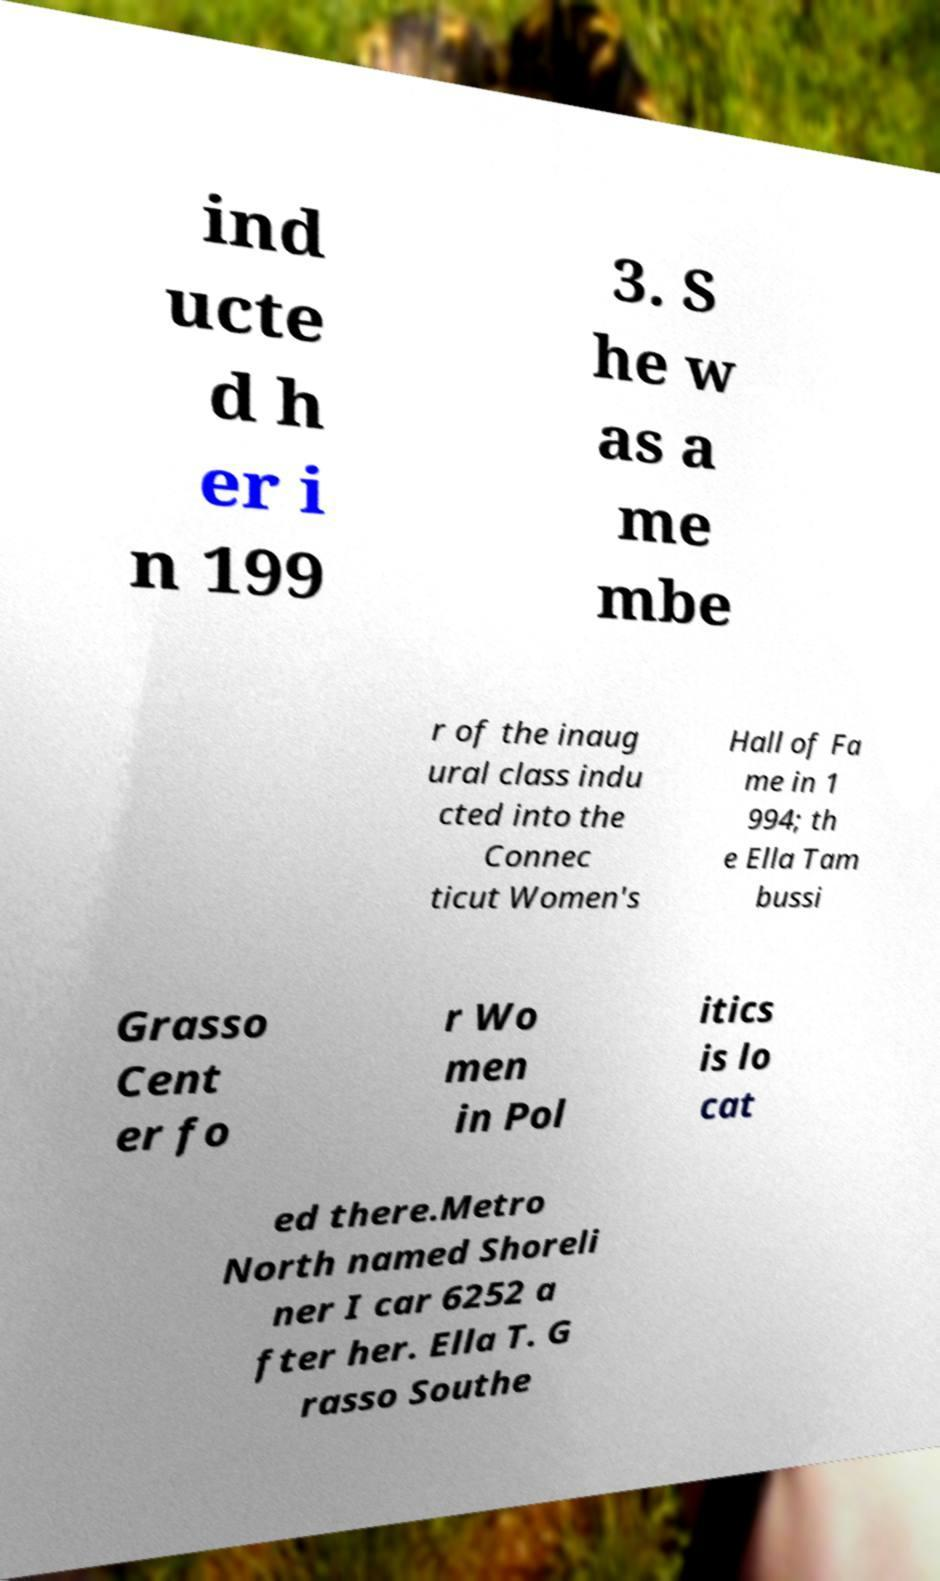Can you accurately transcribe the text from the provided image for me? ind ucte d h er i n 199 3. S he w as a me mbe r of the inaug ural class indu cted into the Connec ticut Women's Hall of Fa me in 1 994; th e Ella Tam bussi Grasso Cent er fo r Wo men in Pol itics is lo cat ed there.Metro North named Shoreli ner I car 6252 a fter her. Ella T. G rasso Southe 